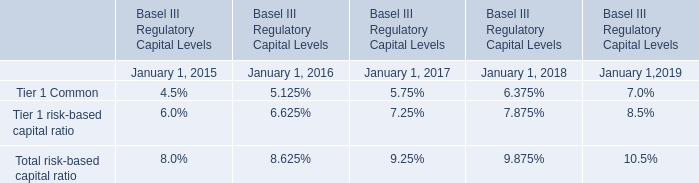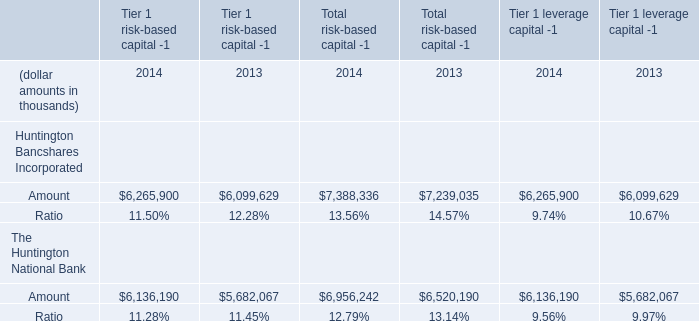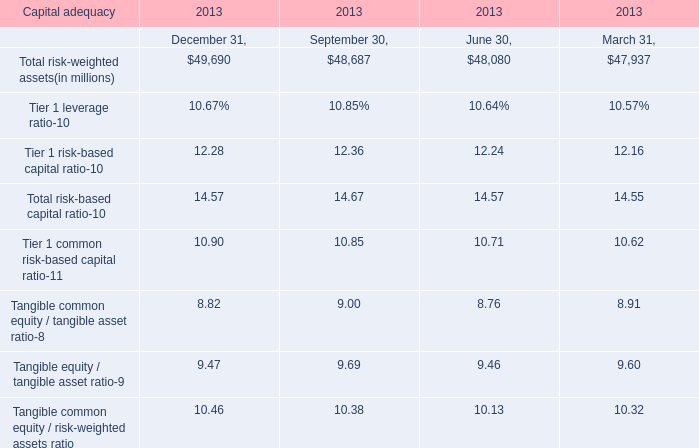What is the amount of the highest value of Total risk-weighted assets? (in million) 
Answer: 49690. 